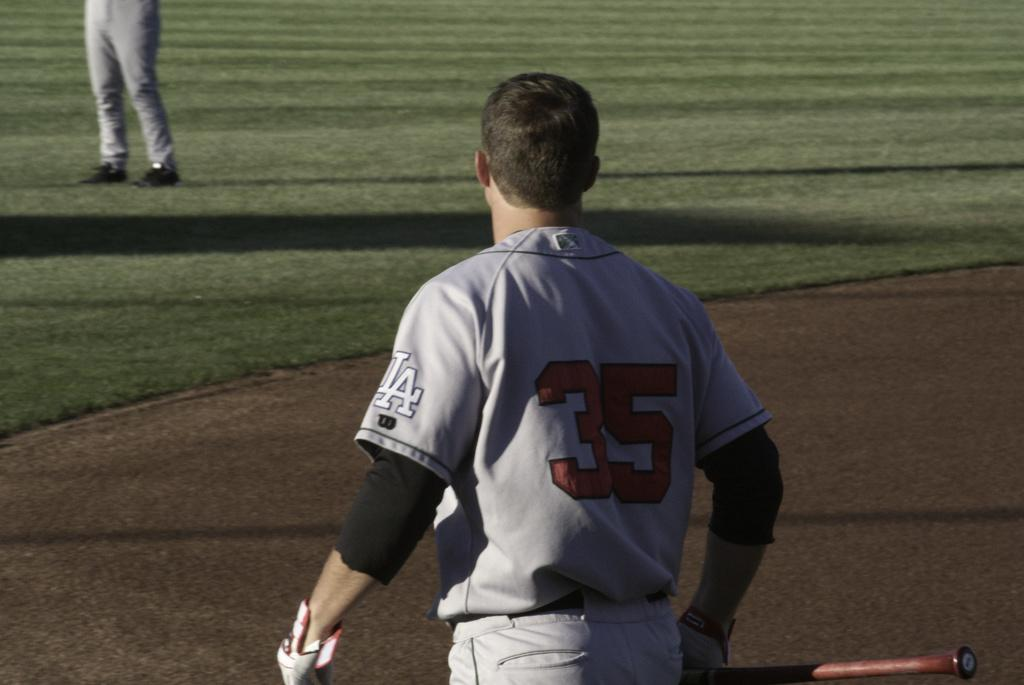<image>
Summarize the visual content of the image. A baseball player with a jersey with the number 35 on it. 